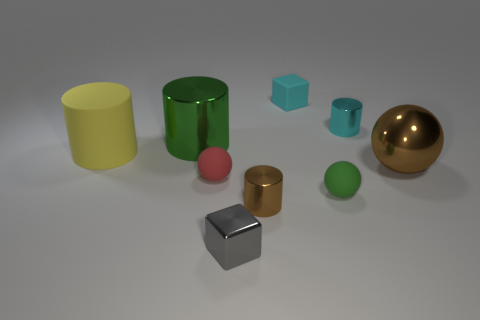Add 1 green matte cubes. How many objects exist? 10 Subtract all spheres. How many objects are left? 6 Subtract 0 yellow cubes. How many objects are left? 9 Subtract all large green things. Subtract all brown things. How many objects are left? 6 Add 2 brown shiny cylinders. How many brown shiny cylinders are left? 3 Add 3 green matte cylinders. How many green matte cylinders exist? 3 